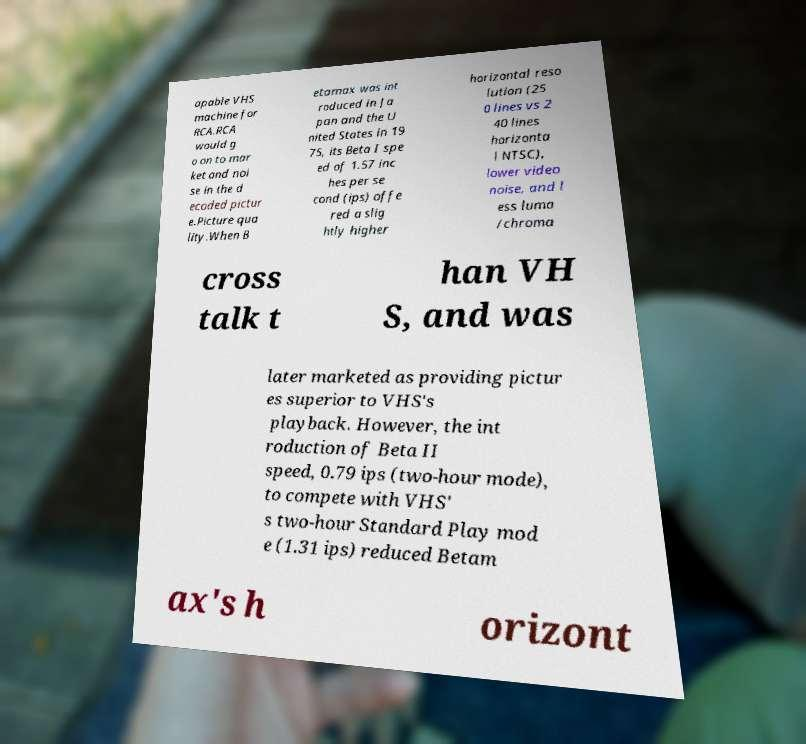Please read and relay the text visible in this image. What does it say? apable VHS machine for RCA.RCA would g o on to mar ket and noi se in the d ecoded pictur e.Picture qua lity.When B etamax was int roduced in Ja pan and the U nited States in 19 75, its Beta I spe ed of 1.57 inc hes per se cond (ips) offe red a slig htly higher horizontal reso lution (25 0 lines vs 2 40 lines horizonta l NTSC), lower video noise, and l ess luma /chroma cross talk t han VH S, and was later marketed as providing pictur es superior to VHS's playback. However, the int roduction of Beta II speed, 0.79 ips (two-hour mode), to compete with VHS' s two-hour Standard Play mod e (1.31 ips) reduced Betam ax's h orizont 